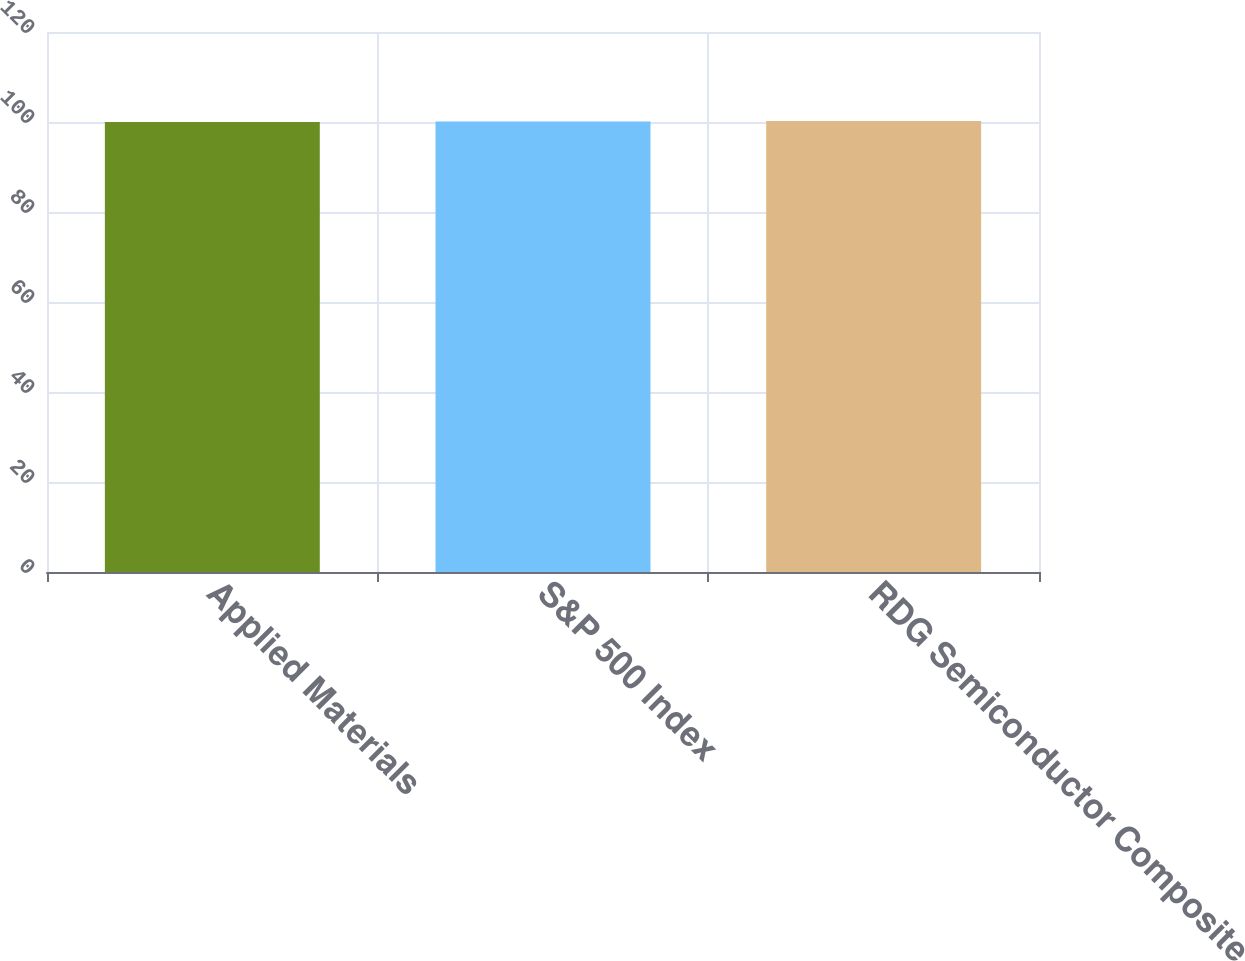Convert chart to OTSL. <chart><loc_0><loc_0><loc_500><loc_500><bar_chart><fcel>Applied Materials<fcel>S&P 500 Index<fcel>RDG Semiconductor Composite<nl><fcel>100<fcel>100.1<fcel>100.2<nl></chart> 